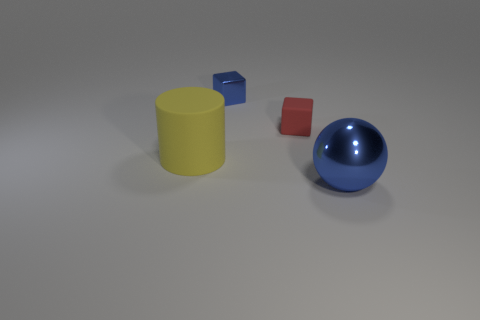Add 3 shiny objects. How many objects exist? 7 Subtract all spheres. How many objects are left? 3 Add 1 big matte cylinders. How many big matte cylinders exist? 2 Subtract 0 green cubes. How many objects are left? 4 Subtract all large yellow matte balls. Subtract all small matte blocks. How many objects are left? 3 Add 1 red matte blocks. How many red matte blocks are left? 2 